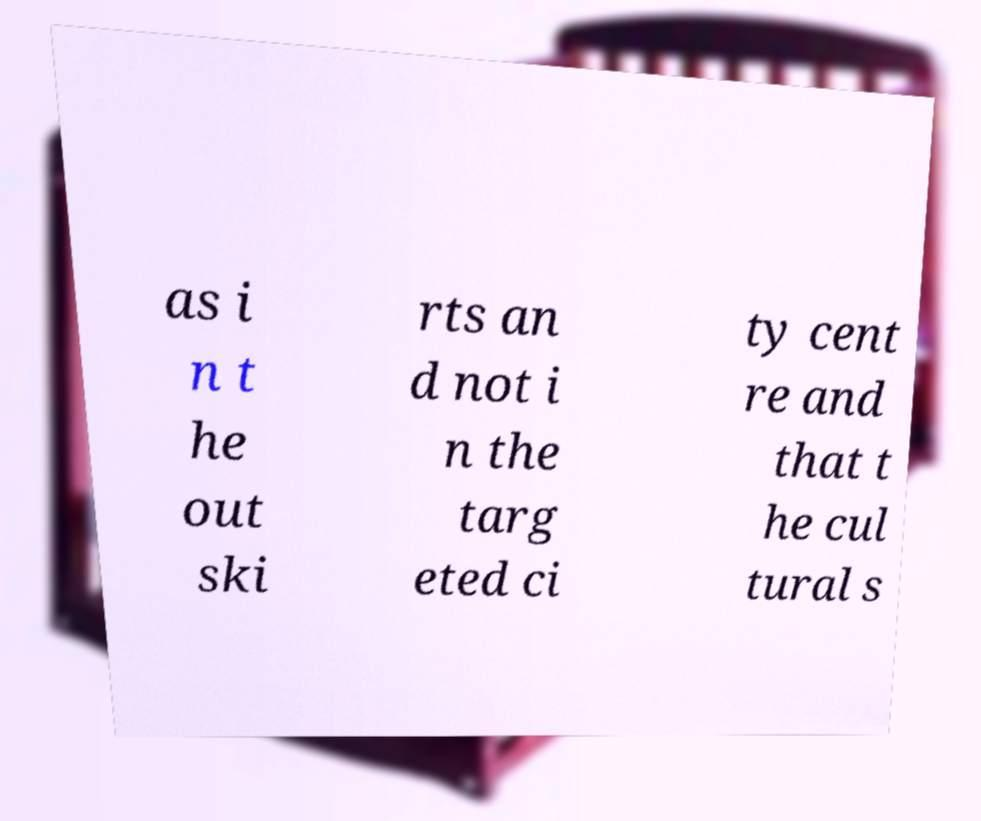There's text embedded in this image that I need extracted. Can you transcribe it verbatim? as i n t he out ski rts an d not i n the targ eted ci ty cent re and that t he cul tural s 